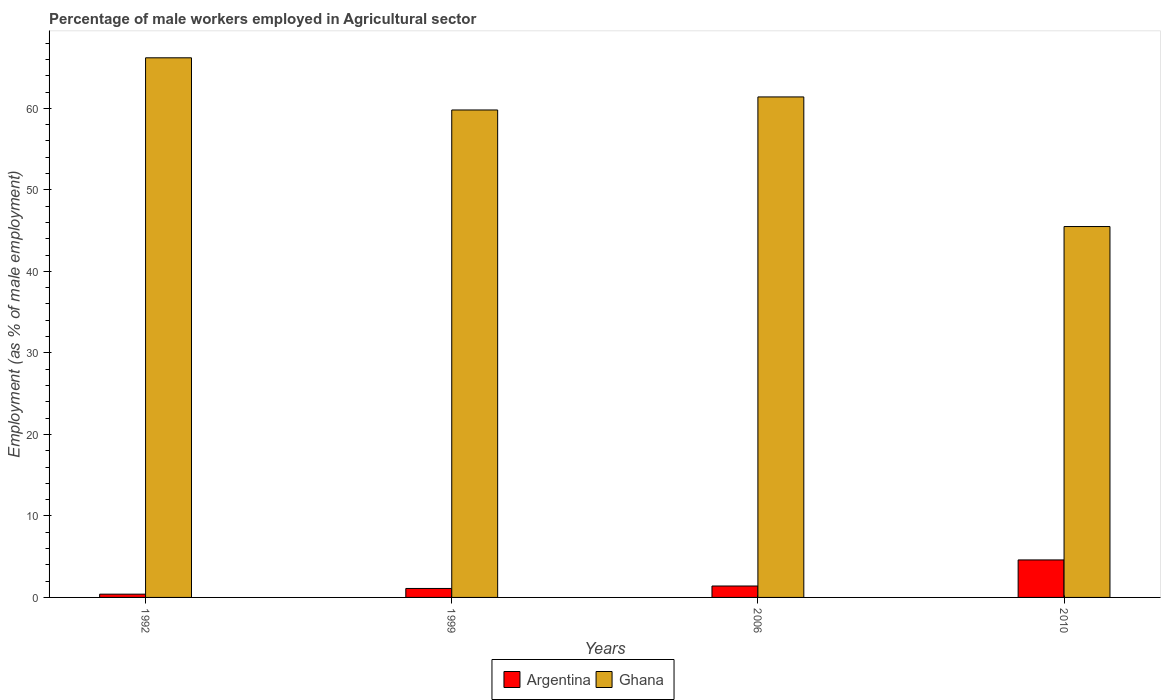How many different coloured bars are there?
Ensure brevity in your answer.  2. Are the number of bars on each tick of the X-axis equal?
Ensure brevity in your answer.  Yes. How many bars are there on the 4th tick from the left?
Give a very brief answer. 2. What is the label of the 3rd group of bars from the left?
Offer a very short reply. 2006. In how many cases, is the number of bars for a given year not equal to the number of legend labels?
Make the answer very short. 0. What is the percentage of male workers employed in Agricultural sector in Ghana in 1992?
Provide a succinct answer. 66.2. Across all years, what is the maximum percentage of male workers employed in Agricultural sector in Argentina?
Ensure brevity in your answer.  4.6. Across all years, what is the minimum percentage of male workers employed in Agricultural sector in Argentina?
Ensure brevity in your answer.  0.4. What is the total percentage of male workers employed in Agricultural sector in Ghana in the graph?
Your answer should be very brief. 232.9. What is the difference between the percentage of male workers employed in Agricultural sector in Ghana in 2006 and that in 2010?
Offer a very short reply. 15.9. What is the difference between the percentage of male workers employed in Agricultural sector in Ghana in 2010 and the percentage of male workers employed in Agricultural sector in Argentina in 2006?
Make the answer very short. 44.1. What is the average percentage of male workers employed in Agricultural sector in Ghana per year?
Your answer should be very brief. 58.22. In the year 1992, what is the difference between the percentage of male workers employed in Agricultural sector in Argentina and percentage of male workers employed in Agricultural sector in Ghana?
Offer a terse response. -65.8. In how many years, is the percentage of male workers employed in Agricultural sector in Argentina greater than 44 %?
Offer a very short reply. 0. What is the ratio of the percentage of male workers employed in Agricultural sector in Ghana in 1999 to that in 2010?
Provide a succinct answer. 1.31. Is the percentage of male workers employed in Agricultural sector in Ghana in 1999 less than that in 2006?
Keep it short and to the point. Yes. Is the difference between the percentage of male workers employed in Agricultural sector in Argentina in 2006 and 2010 greater than the difference between the percentage of male workers employed in Agricultural sector in Ghana in 2006 and 2010?
Your answer should be very brief. No. What is the difference between the highest and the second highest percentage of male workers employed in Agricultural sector in Ghana?
Your answer should be compact. 4.8. What is the difference between the highest and the lowest percentage of male workers employed in Agricultural sector in Ghana?
Your response must be concise. 20.7. Is the sum of the percentage of male workers employed in Agricultural sector in Ghana in 1992 and 1999 greater than the maximum percentage of male workers employed in Agricultural sector in Argentina across all years?
Ensure brevity in your answer.  Yes. What does the 2nd bar from the left in 2010 represents?
Ensure brevity in your answer.  Ghana. What is the difference between two consecutive major ticks on the Y-axis?
Offer a very short reply. 10. Does the graph contain any zero values?
Offer a terse response. No. Does the graph contain grids?
Your answer should be very brief. No. How are the legend labels stacked?
Provide a short and direct response. Horizontal. What is the title of the graph?
Your answer should be compact. Percentage of male workers employed in Agricultural sector. Does "Monaco" appear as one of the legend labels in the graph?
Offer a very short reply. No. What is the label or title of the Y-axis?
Your answer should be compact. Employment (as % of male employment). What is the Employment (as % of male employment) of Argentina in 1992?
Ensure brevity in your answer.  0.4. What is the Employment (as % of male employment) of Ghana in 1992?
Offer a terse response. 66.2. What is the Employment (as % of male employment) in Argentina in 1999?
Ensure brevity in your answer.  1.1. What is the Employment (as % of male employment) of Ghana in 1999?
Give a very brief answer. 59.8. What is the Employment (as % of male employment) of Argentina in 2006?
Your answer should be very brief. 1.4. What is the Employment (as % of male employment) of Ghana in 2006?
Provide a succinct answer. 61.4. What is the Employment (as % of male employment) in Argentina in 2010?
Your response must be concise. 4.6. What is the Employment (as % of male employment) in Ghana in 2010?
Your answer should be very brief. 45.5. Across all years, what is the maximum Employment (as % of male employment) of Argentina?
Make the answer very short. 4.6. Across all years, what is the maximum Employment (as % of male employment) of Ghana?
Offer a very short reply. 66.2. Across all years, what is the minimum Employment (as % of male employment) in Argentina?
Your answer should be very brief. 0.4. Across all years, what is the minimum Employment (as % of male employment) in Ghana?
Make the answer very short. 45.5. What is the total Employment (as % of male employment) of Ghana in the graph?
Your response must be concise. 232.9. What is the difference between the Employment (as % of male employment) of Ghana in 1992 and that in 1999?
Ensure brevity in your answer.  6.4. What is the difference between the Employment (as % of male employment) of Ghana in 1992 and that in 2006?
Your response must be concise. 4.8. What is the difference between the Employment (as % of male employment) in Ghana in 1992 and that in 2010?
Make the answer very short. 20.7. What is the difference between the Employment (as % of male employment) in Argentina in 1992 and the Employment (as % of male employment) in Ghana in 1999?
Provide a succinct answer. -59.4. What is the difference between the Employment (as % of male employment) of Argentina in 1992 and the Employment (as % of male employment) of Ghana in 2006?
Your response must be concise. -61. What is the difference between the Employment (as % of male employment) of Argentina in 1992 and the Employment (as % of male employment) of Ghana in 2010?
Offer a very short reply. -45.1. What is the difference between the Employment (as % of male employment) of Argentina in 1999 and the Employment (as % of male employment) of Ghana in 2006?
Your answer should be compact. -60.3. What is the difference between the Employment (as % of male employment) in Argentina in 1999 and the Employment (as % of male employment) in Ghana in 2010?
Provide a succinct answer. -44.4. What is the difference between the Employment (as % of male employment) in Argentina in 2006 and the Employment (as % of male employment) in Ghana in 2010?
Your answer should be compact. -44.1. What is the average Employment (as % of male employment) of Argentina per year?
Your response must be concise. 1.88. What is the average Employment (as % of male employment) in Ghana per year?
Make the answer very short. 58.23. In the year 1992, what is the difference between the Employment (as % of male employment) of Argentina and Employment (as % of male employment) of Ghana?
Ensure brevity in your answer.  -65.8. In the year 1999, what is the difference between the Employment (as % of male employment) of Argentina and Employment (as % of male employment) of Ghana?
Make the answer very short. -58.7. In the year 2006, what is the difference between the Employment (as % of male employment) in Argentina and Employment (as % of male employment) in Ghana?
Offer a very short reply. -60. In the year 2010, what is the difference between the Employment (as % of male employment) in Argentina and Employment (as % of male employment) in Ghana?
Your answer should be very brief. -40.9. What is the ratio of the Employment (as % of male employment) of Argentina in 1992 to that in 1999?
Your response must be concise. 0.36. What is the ratio of the Employment (as % of male employment) in Ghana in 1992 to that in 1999?
Offer a very short reply. 1.11. What is the ratio of the Employment (as % of male employment) in Argentina in 1992 to that in 2006?
Give a very brief answer. 0.29. What is the ratio of the Employment (as % of male employment) of Ghana in 1992 to that in 2006?
Keep it short and to the point. 1.08. What is the ratio of the Employment (as % of male employment) of Argentina in 1992 to that in 2010?
Make the answer very short. 0.09. What is the ratio of the Employment (as % of male employment) of Ghana in 1992 to that in 2010?
Offer a very short reply. 1.45. What is the ratio of the Employment (as % of male employment) of Argentina in 1999 to that in 2006?
Your answer should be compact. 0.79. What is the ratio of the Employment (as % of male employment) of Ghana in 1999 to that in 2006?
Offer a very short reply. 0.97. What is the ratio of the Employment (as % of male employment) in Argentina in 1999 to that in 2010?
Your answer should be compact. 0.24. What is the ratio of the Employment (as % of male employment) of Ghana in 1999 to that in 2010?
Provide a short and direct response. 1.31. What is the ratio of the Employment (as % of male employment) in Argentina in 2006 to that in 2010?
Offer a terse response. 0.3. What is the ratio of the Employment (as % of male employment) in Ghana in 2006 to that in 2010?
Your answer should be very brief. 1.35. What is the difference between the highest and the lowest Employment (as % of male employment) in Argentina?
Ensure brevity in your answer.  4.2. What is the difference between the highest and the lowest Employment (as % of male employment) in Ghana?
Make the answer very short. 20.7. 